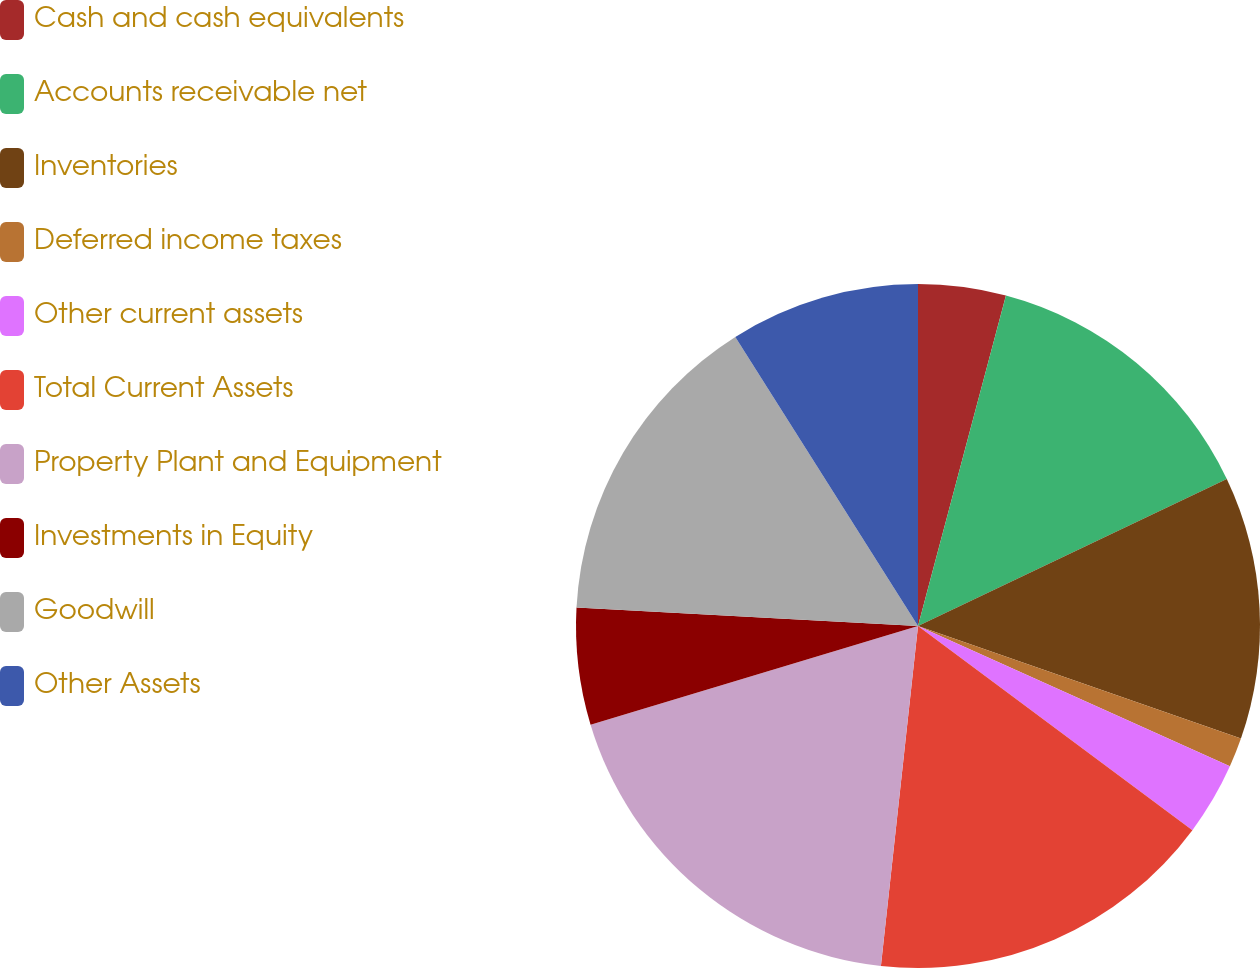Convert chart. <chart><loc_0><loc_0><loc_500><loc_500><pie_chart><fcel>Cash and cash equivalents<fcel>Accounts receivable net<fcel>Inventories<fcel>Deferred income taxes<fcel>Other current assets<fcel>Total Current Assets<fcel>Property Plant and Equipment<fcel>Investments in Equity<fcel>Goodwill<fcel>Other Assets<nl><fcel>4.14%<fcel>13.79%<fcel>12.41%<fcel>1.39%<fcel>3.45%<fcel>16.55%<fcel>18.61%<fcel>5.52%<fcel>15.17%<fcel>8.97%<nl></chart> 